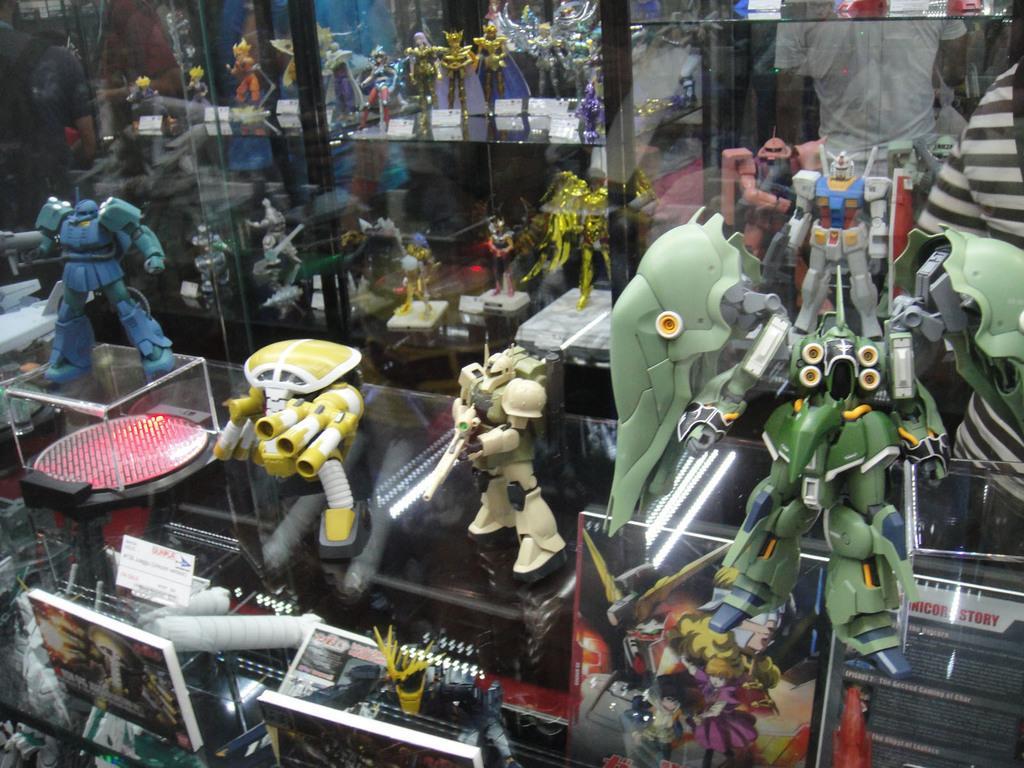Can you describe this image briefly? In this image I can see many toys on the glass surface. These toys are colorful. I can also see the boards in-front of the toys. To the right I can see few people with different color dresses. 